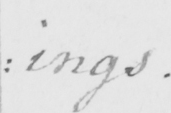Can you read and transcribe this handwriting? : ings . 